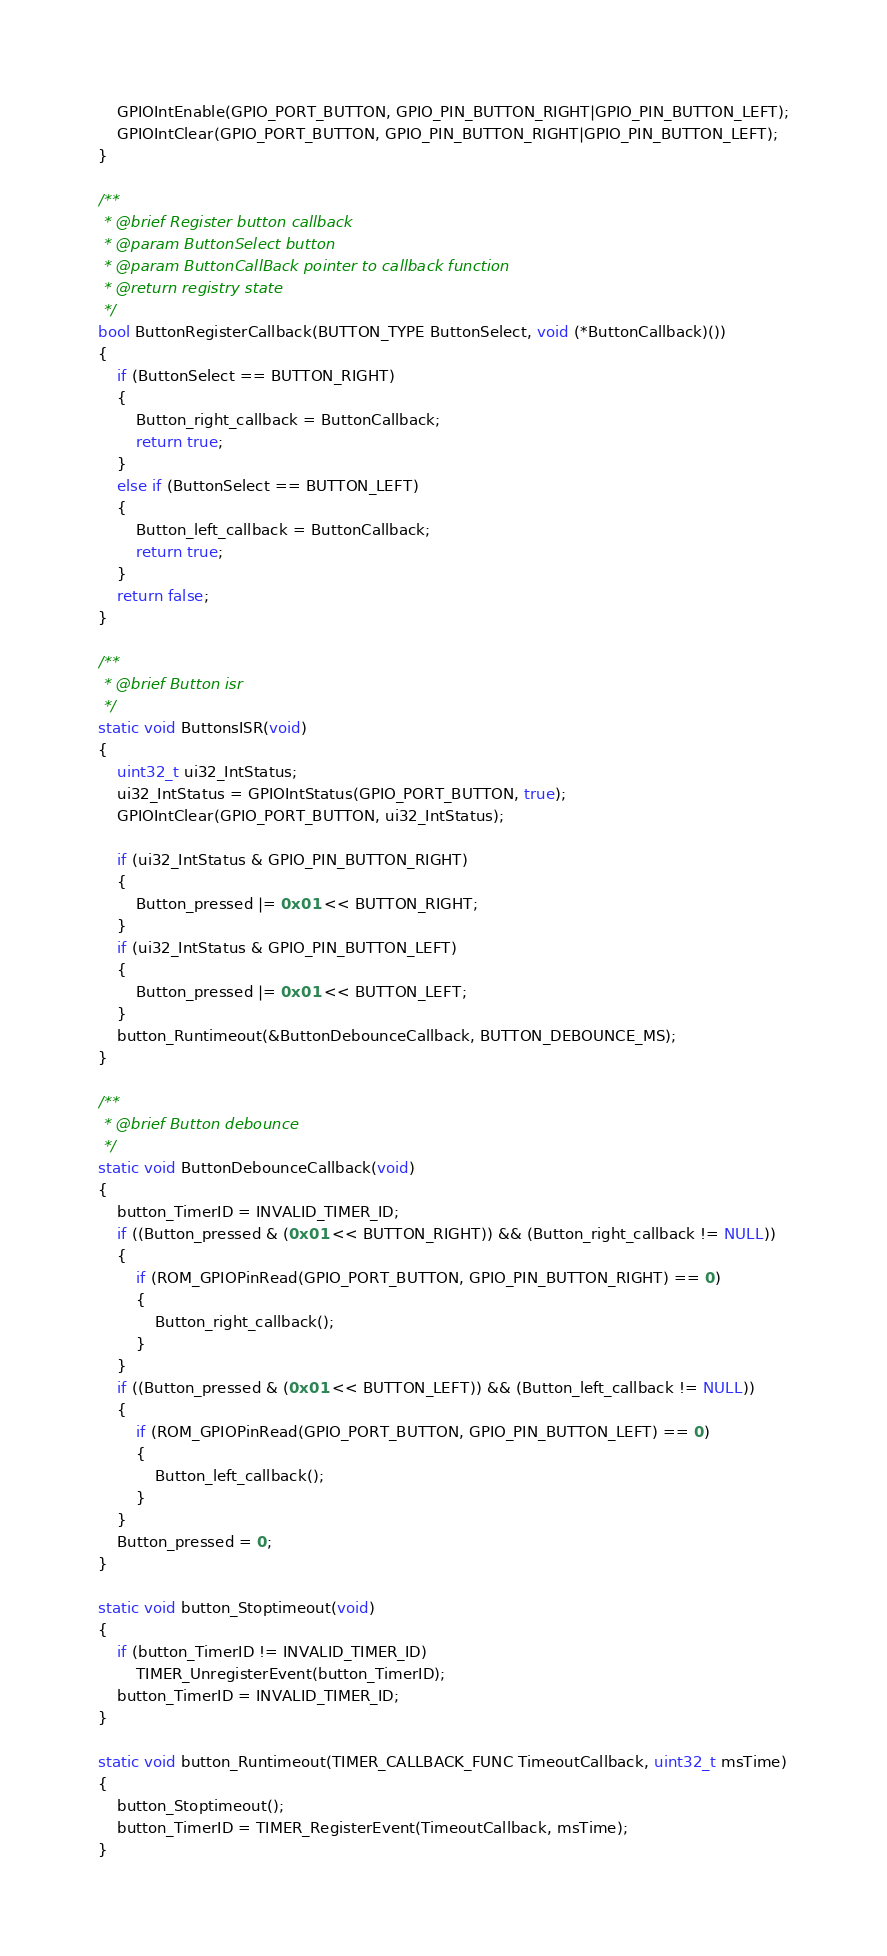Convert code to text. <code><loc_0><loc_0><loc_500><loc_500><_C_>	GPIOIntEnable(GPIO_PORT_BUTTON, GPIO_PIN_BUTTON_RIGHT|GPIO_PIN_BUTTON_LEFT);
	GPIOIntClear(GPIO_PORT_BUTTON, GPIO_PIN_BUTTON_RIGHT|GPIO_PIN_BUTTON_LEFT);
}

/**
 * @brief Register button callback
 * @param ButtonSelect button
 * @param ButtonCallBack pointer to callback function
 * @return registry state
 */
bool ButtonRegisterCallback(BUTTON_TYPE ButtonSelect, void (*ButtonCallback)())
{
	if (ButtonSelect == BUTTON_RIGHT)
	{
		Button_right_callback = ButtonCallback;
		return true;
	}
	else if (ButtonSelect == BUTTON_LEFT)
	{
		Button_left_callback = ButtonCallback;
		return true;
	}
	return false;
}

/**
 * @brief Button isr
 */
static void ButtonsISR(void)
{
	uint32_t ui32_IntStatus;
	ui32_IntStatus = GPIOIntStatus(GPIO_PORT_BUTTON, true);
	GPIOIntClear(GPIO_PORT_BUTTON, ui32_IntStatus);

	if (ui32_IntStatus & GPIO_PIN_BUTTON_RIGHT)
	{
		Button_pressed |= 0x01 << BUTTON_RIGHT;
	}
	if (ui32_IntStatus & GPIO_PIN_BUTTON_LEFT)
	{
		Button_pressed |= 0x01 << BUTTON_LEFT;
	}
	button_Runtimeout(&ButtonDebounceCallback, BUTTON_DEBOUNCE_MS);
}

/**
 * @brief Button debounce
 */
static void ButtonDebounceCallback(void)
{
	button_TimerID = INVALID_TIMER_ID;
	if ((Button_pressed & (0x01 << BUTTON_RIGHT)) && (Button_right_callback != NULL))
	{
		if (ROM_GPIOPinRead(GPIO_PORT_BUTTON, GPIO_PIN_BUTTON_RIGHT) == 0)
		{
			Button_right_callback();
		}
	}
	if ((Button_pressed & (0x01 << BUTTON_LEFT)) && (Button_left_callback != NULL))
	{
		if (ROM_GPIOPinRead(GPIO_PORT_BUTTON, GPIO_PIN_BUTTON_LEFT) == 0)
		{
			Button_left_callback();
		}
	}
	Button_pressed = 0;
}

static void button_Stoptimeout(void)
{
	if (button_TimerID != INVALID_TIMER_ID)
		TIMER_UnregisterEvent(button_TimerID);
	button_TimerID = INVALID_TIMER_ID;
}

static void button_Runtimeout(TIMER_CALLBACK_FUNC TimeoutCallback, uint32_t msTime)
{
	button_Stoptimeout();
	button_TimerID = TIMER_RegisterEvent(TimeoutCallback, msTime);
}

</code> 